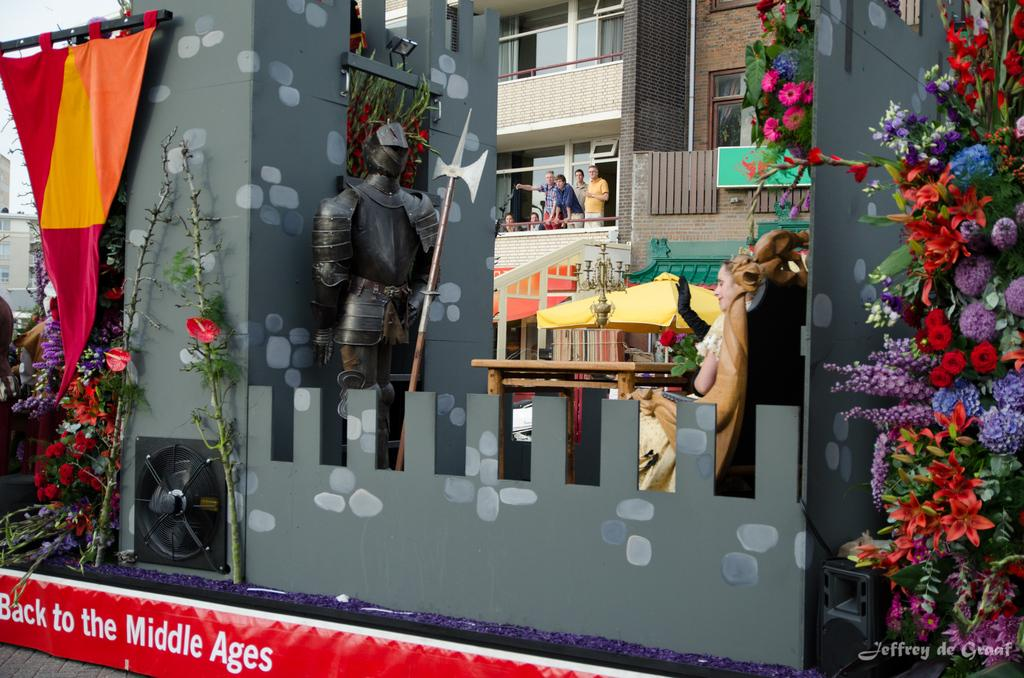<image>
Share a concise interpretation of the image provided. A storefront with stuff in the window and "Back to the Middle Ages" written below. 